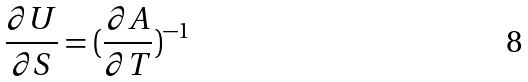<formula> <loc_0><loc_0><loc_500><loc_500>\frac { \partial U } { \partial S } = ( \frac { \partial A } { \partial T } ) ^ { - 1 }</formula> 